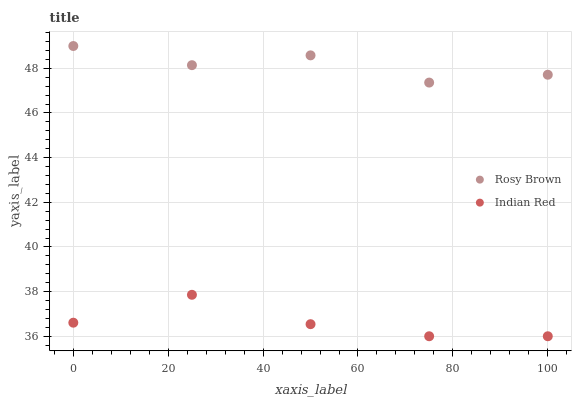Does Indian Red have the minimum area under the curve?
Answer yes or no. Yes. Does Rosy Brown have the maximum area under the curve?
Answer yes or no. Yes. Does Indian Red have the maximum area under the curve?
Answer yes or no. No. Is Indian Red the smoothest?
Answer yes or no. Yes. Is Rosy Brown the roughest?
Answer yes or no. Yes. Is Indian Red the roughest?
Answer yes or no. No. Does Indian Red have the lowest value?
Answer yes or no. Yes. Does Rosy Brown have the highest value?
Answer yes or no. Yes. Does Indian Red have the highest value?
Answer yes or no. No. Is Indian Red less than Rosy Brown?
Answer yes or no. Yes. Is Rosy Brown greater than Indian Red?
Answer yes or no. Yes. Does Indian Red intersect Rosy Brown?
Answer yes or no. No. 